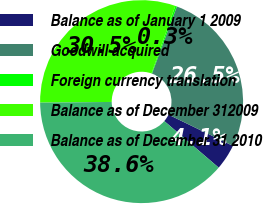Convert chart. <chart><loc_0><loc_0><loc_500><loc_500><pie_chart><fcel>Balance as of January 1 2009<fcel>Goodwill acquired<fcel>Foreign currency translation<fcel>Balance as of December 312009<fcel>Balance as of December 31 2010<nl><fcel>4.09%<fcel>26.53%<fcel>0.26%<fcel>30.55%<fcel>38.57%<nl></chart> 